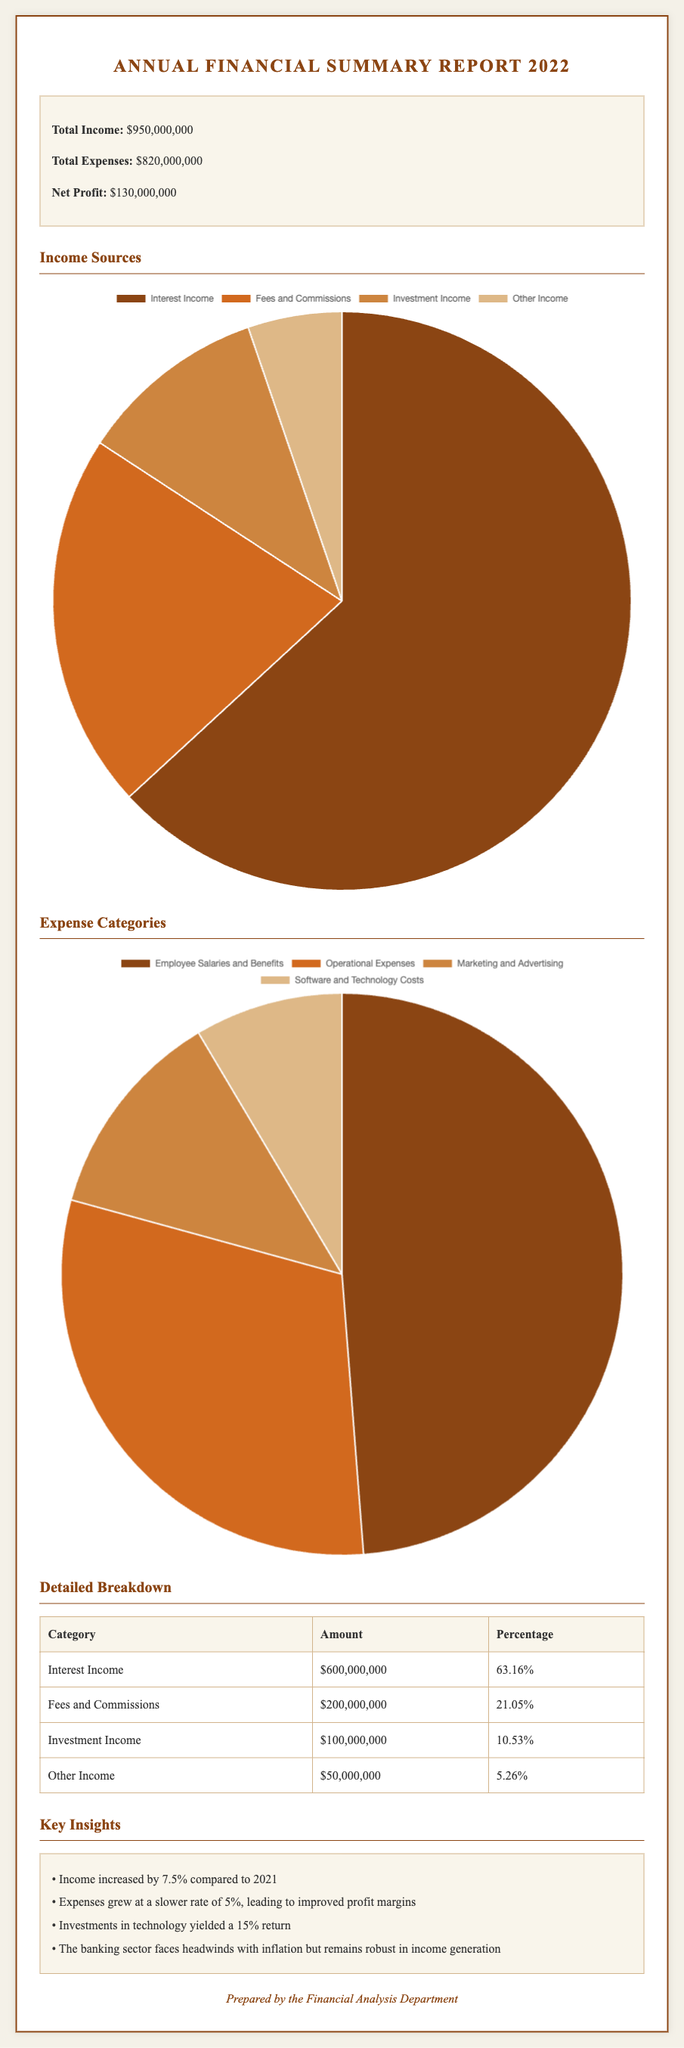What is the total income? The total income is stated in the summary section of the document.
Answer: $950,000,000 What is the net profit? The net profit is the result after subtracting total expenses from total income.
Answer: $130,000,000 Which income source contributes the most? The income sources section breaks down contributions and shows that interest income is the largest.
Answer: Interest Income What percentage of total income comes from fees and commissions? The detailed breakdown indicates the percentage of total income derived from fees and commissions.
Answer: 21.05% What is the total expenses amount? The total expenses figure is provided in the summary section.
Answer: $820,000,000 What category has the highest expense? The expense categories pie chart suggests which category bears the most weight among expenses.
Answer: Employee Salaries and Benefits By what percentage did income increase compared to 2021? The key insights section provides the percentage increase in income compared to the previous year.
Answer: 7.5% What was the return on investments in technology? The insights mention the financial return achieved from investments in technology.
Answer: 15% Which department prepared this report? The footer contains information about who prepared the document, specifically the department.
Answer: Financial Analysis Department 